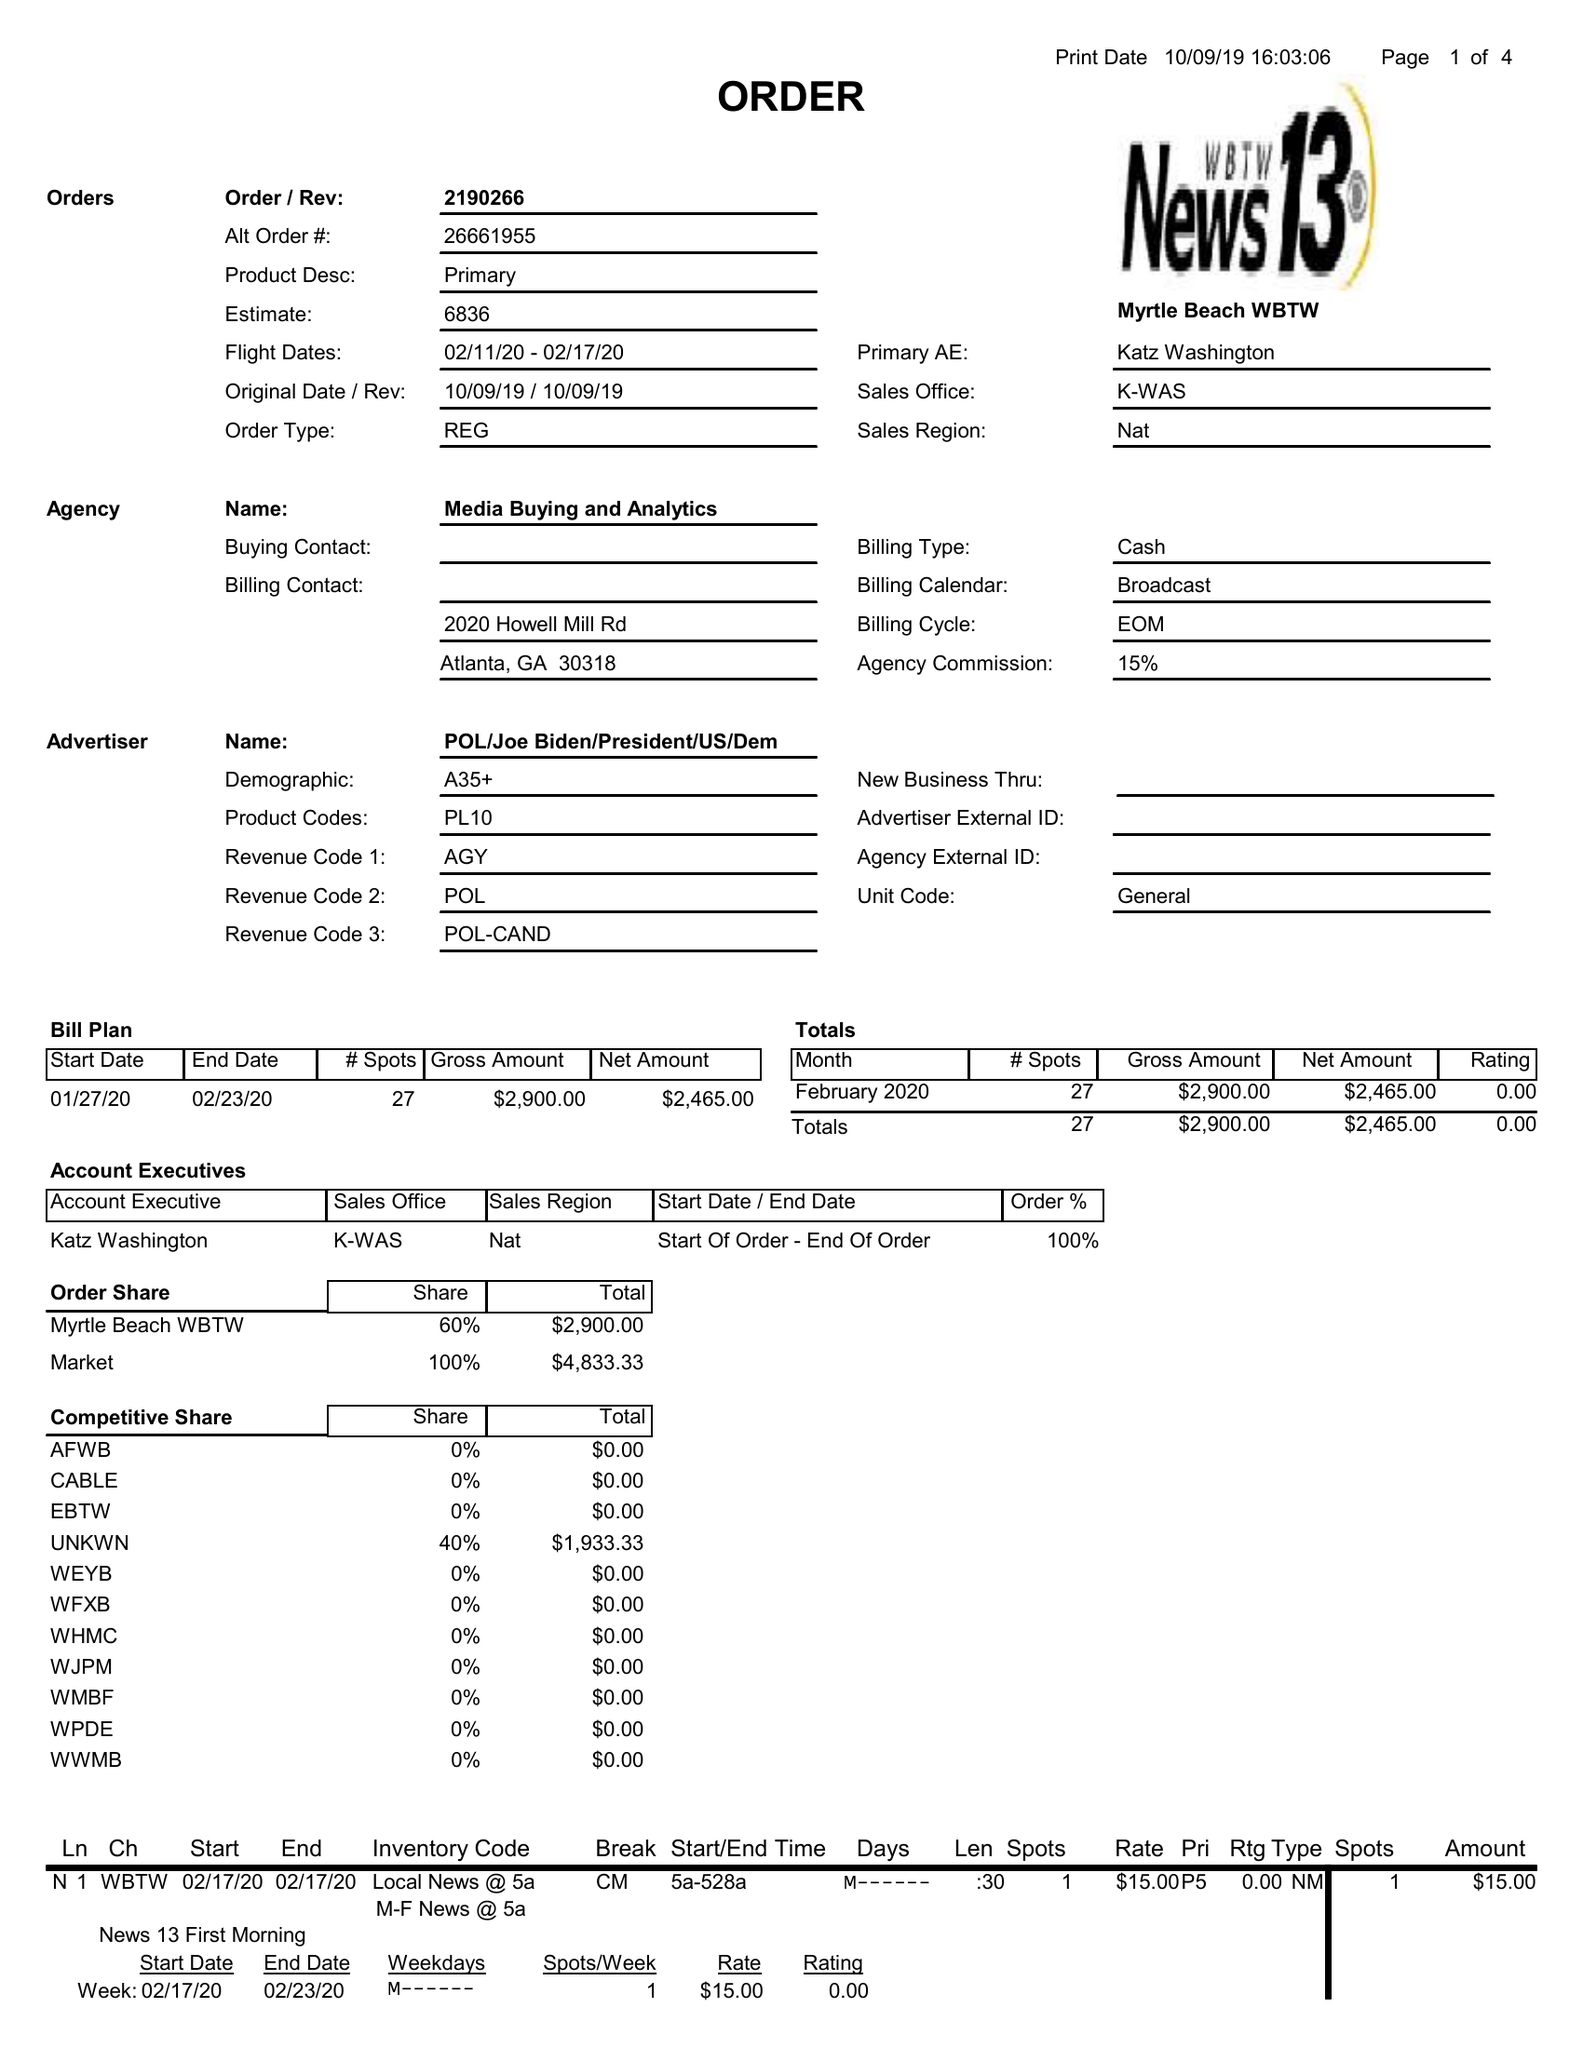What is the value for the contract_num?
Answer the question using a single word or phrase. 2190266 